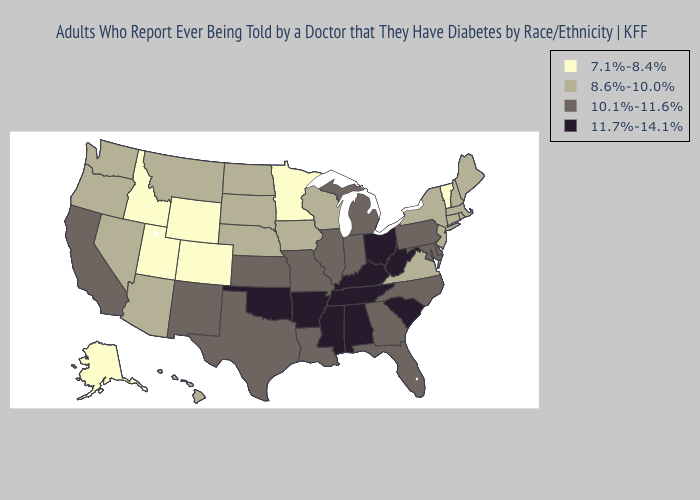Among the states that border Wyoming , which have the highest value?
Quick response, please. Montana, Nebraska, South Dakota. Does Nebraska have a lower value than Kansas?
Keep it brief. Yes. Does Wisconsin have the lowest value in the MidWest?
Quick response, please. No. Name the states that have a value in the range 10.1%-11.6%?
Short answer required. California, Delaware, Florida, Georgia, Illinois, Indiana, Kansas, Louisiana, Maryland, Michigan, Missouri, New Mexico, North Carolina, Pennsylvania, Texas. How many symbols are there in the legend?
Quick response, please. 4. Among the states that border Alabama , does Florida have the highest value?
Give a very brief answer. No. Does Indiana have the lowest value in the USA?
Short answer required. No. Name the states that have a value in the range 11.7%-14.1%?
Answer briefly. Alabama, Arkansas, Kentucky, Mississippi, Ohio, Oklahoma, South Carolina, Tennessee, West Virginia. Among the states that border Montana , which have the highest value?
Answer briefly. North Dakota, South Dakota. What is the highest value in the South ?
Keep it brief. 11.7%-14.1%. Does the map have missing data?
Be succinct. No. How many symbols are there in the legend?
Give a very brief answer. 4. What is the value of Montana?
Be succinct. 8.6%-10.0%. Name the states that have a value in the range 8.6%-10.0%?
Keep it brief. Arizona, Connecticut, Hawaii, Iowa, Maine, Massachusetts, Montana, Nebraska, Nevada, New Hampshire, New Jersey, New York, North Dakota, Oregon, Rhode Island, South Dakota, Virginia, Washington, Wisconsin. 